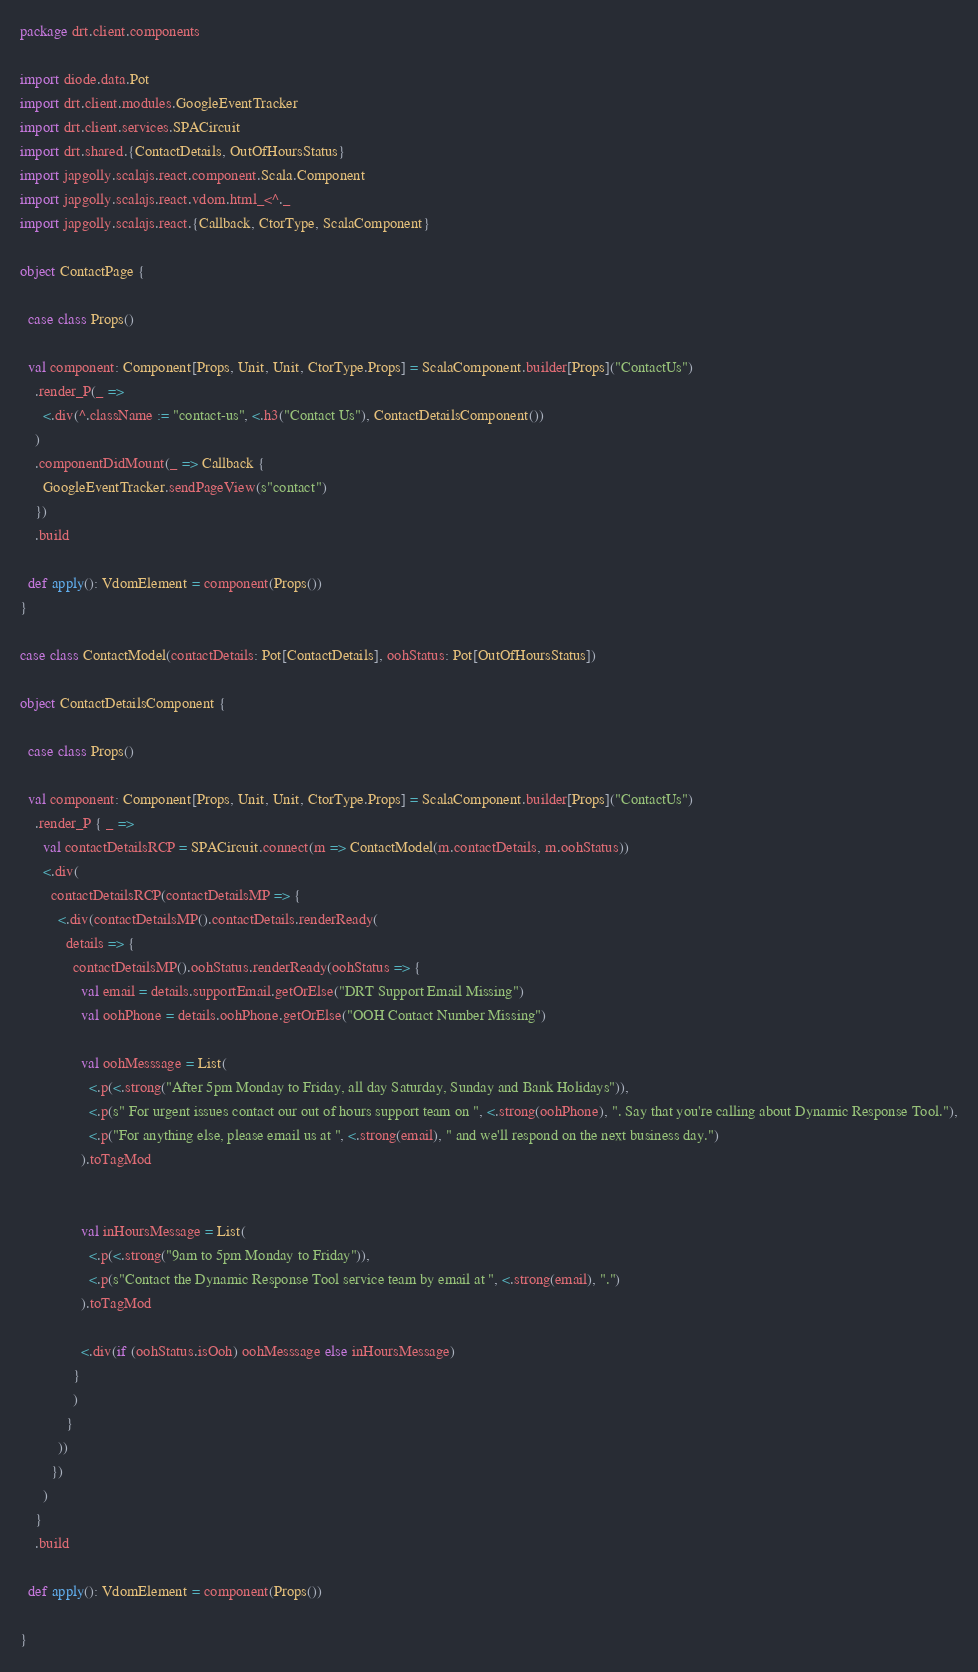Convert code to text. <code><loc_0><loc_0><loc_500><loc_500><_Scala_>package drt.client.components

import diode.data.Pot
import drt.client.modules.GoogleEventTracker
import drt.client.services.SPACircuit
import drt.shared.{ContactDetails, OutOfHoursStatus}
import japgolly.scalajs.react.component.Scala.Component
import japgolly.scalajs.react.vdom.html_<^._
import japgolly.scalajs.react.{Callback, CtorType, ScalaComponent}

object ContactPage {

  case class Props()

  val component: Component[Props, Unit, Unit, CtorType.Props] = ScalaComponent.builder[Props]("ContactUs")
    .render_P(_ =>
      <.div(^.className := "contact-us", <.h3("Contact Us"), ContactDetailsComponent())
    )
    .componentDidMount(_ => Callback {
      GoogleEventTracker.sendPageView(s"contact")
    })
    .build

  def apply(): VdomElement = component(Props())
}

case class ContactModel(contactDetails: Pot[ContactDetails], oohStatus: Pot[OutOfHoursStatus])

object ContactDetailsComponent {

  case class Props()

  val component: Component[Props, Unit, Unit, CtorType.Props] = ScalaComponent.builder[Props]("ContactUs")
    .render_P { _ =>
      val contactDetailsRCP = SPACircuit.connect(m => ContactModel(m.contactDetails, m.oohStatus))
      <.div(
        contactDetailsRCP(contactDetailsMP => {
          <.div(contactDetailsMP().contactDetails.renderReady(
            details => {
              contactDetailsMP().oohStatus.renderReady(oohStatus => {
                val email = details.supportEmail.getOrElse("DRT Support Email Missing")
                val oohPhone = details.oohPhone.getOrElse("OOH Contact Number Missing")

                val oohMesssage = List(
                  <.p(<.strong("After 5pm Monday to Friday, all day Saturday, Sunday and Bank Holidays")),
                  <.p(s" For urgent issues contact our out of hours support team on ", <.strong(oohPhone), ". Say that you're calling about Dynamic Response Tool."),
                  <.p("For anything else, please email us at ", <.strong(email), " and we'll respond on the next business day.")
                ).toTagMod


                val inHoursMessage = List(
                  <.p(<.strong("9am to 5pm Monday to Friday")),
                  <.p(s"Contact the Dynamic Response Tool service team by email at ", <.strong(email), ".")
                ).toTagMod

                <.div(if (oohStatus.isOoh) oohMesssage else inHoursMessage)
              }
              )
            }
          ))
        })
      )
    }
    .build

  def apply(): VdomElement = component(Props())

}
</code> 